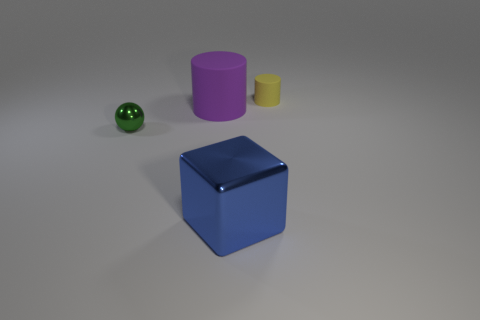Describe the largest object in the image. The largest object in the image is a purple cylinder. Its considerable size dominates the arrangement of shapes, and its smooth surface reflects a bit of the light, emphasizing its solid color. 